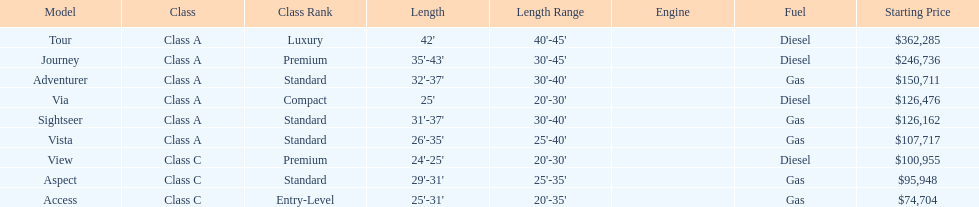Which model has the lowest started price? Access. 